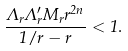Convert formula to latex. <formula><loc_0><loc_0><loc_500><loc_500>\frac { \Lambda _ { r } \Lambda ^ { \prime } _ { r } M _ { r } r ^ { 2 n } } { 1 / r - r } < 1 .</formula> 